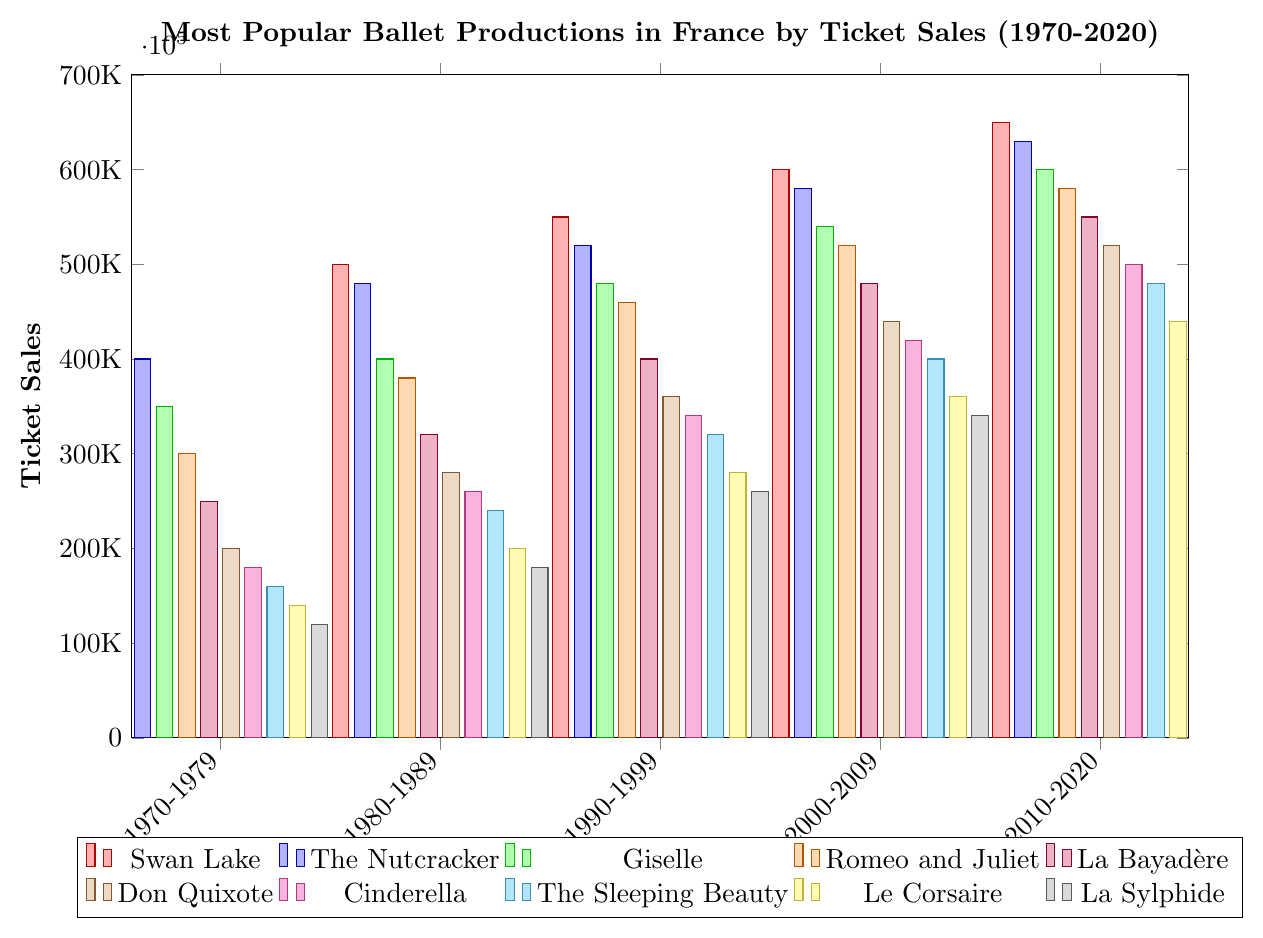Which ballet production had the highest ticket sales in the 1970s? Look at the y-values of the bars for the decade 1970-1979. Swan Lake has the highest ticket sales of 450,000.
Answer: Swan Lake How many more tickets did The Nutcracker sell in the 2010s compared to the 1970s? The ticket sales for The Nutcracker in the 2010s and 1970s are 630,000 and 400,000 respectively. Subtract the 1970s sales from the 2010s sales: 630,000 - 400,000 = 230,000.
Answer: 230,000 Which production had the lowest increase in ticket sales from the 1970s to the 2010s? Calculate the increase for each production by subtracting the ticket sales in the 1970s from those in the 2010s. La Sylphide has the smallest increase of 300,000 (420,000 - 120,000).
Answer: La Sylphide What's the average ticket sales for Giselle across all decades? Sum the ticket sales for Giselle across all decades and divide by the number of decades: (350,000 + 400,000 + 480,000 + 540,000 + 600,000) / 5 = 474,000.
Answer: 474,000 Which two productions had equal ticket sales in the decade 1980-1989? Compare the ticket sales for all productions in the 1980-1989 decade. Cinderella and Le Corsaire both had ticket sales of 200,000.
Answer: Cinderella and Le Corsaire Is the growth in ticket sales for Romeo and Juliet consistent across all decades? Look at the ticket sales for Romeo and Juliet: 300,000, 380,000, 460,000, 520,000, 580,000. Calculate the differences for each successive decade: 80,000, 80,000, 60,000, 60,000. The growth is not perfectly consistent, with slight variations.
Answer: No How much did ticket sales increase for La Sleeping Beauty from 1990-1999 to 2010-2020? The ticket sales for La Sleeping Beauty in 1990-1999 and 2010-2020 are 320,000 and 480,000 respectively. Subtract the 1990-1999 sales from the 2010-2020 sales: 480,000 - 320,000 = 160,000.
Answer: 160,000 Which production had the most significant percentage increase in ticket sales between the 1970s and 2010s? To find the percentage increase, calculate: ((2010s Ticket Sales - 1970s Ticket Sales) / 1970s Ticket Sales) * 100. The Nutcracker had a significant increase: ((630,000 - 400,000) / 400,000) * 100 = 57.5%.
Answer: The Nutcracker 